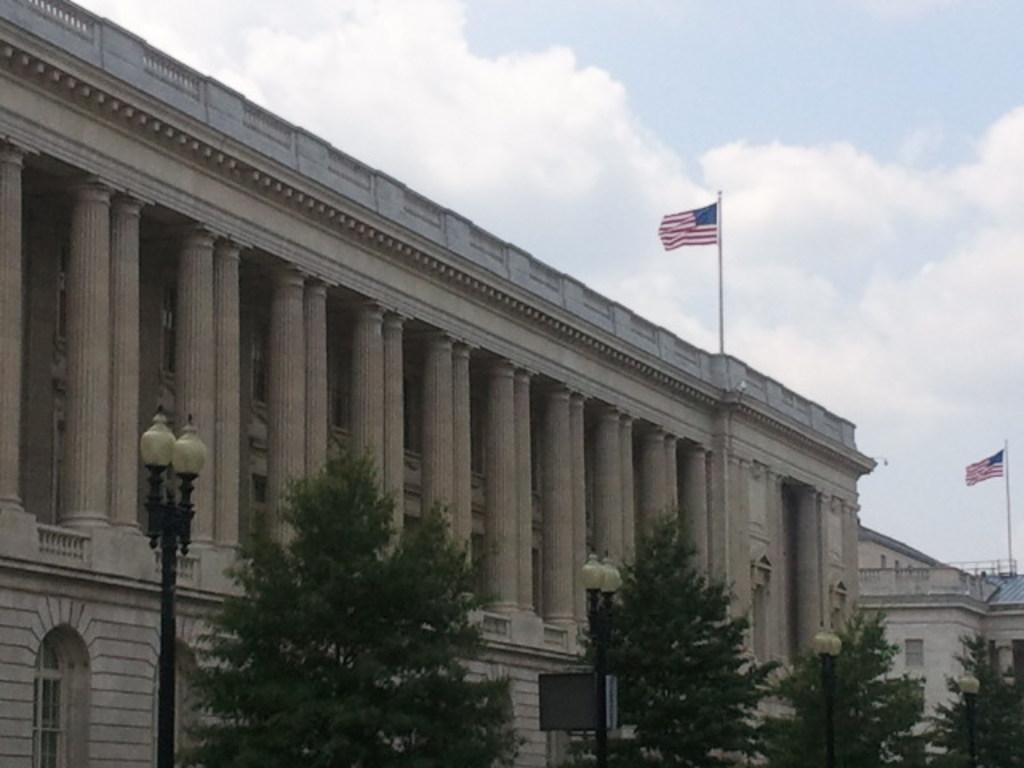What type of structure is visible in the image? There is a building in the image. What decorations are on the building? There are flags on the building. What other objects can be seen in the image? There are poles with lamps and trees in the image. How many boys are playing with the theory in the image? There are no boys or theories present in the image. 